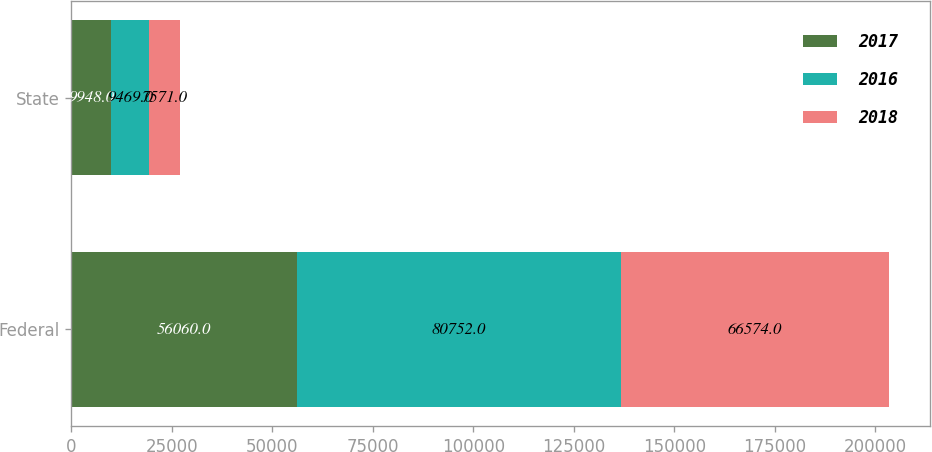Convert chart to OTSL. <chart><loc_0><loc_0><loc_500><loc_500><stacked_bar_chart><ecel><fcel>Federal<fcel>State<nl><fcel>2017<fcel>56060<fcel>9948<nl><fcel>2016<fcel>80752<fcel>9469<nl><fcel>2018<fcel>66574<fcel>7571<nl></chart> 